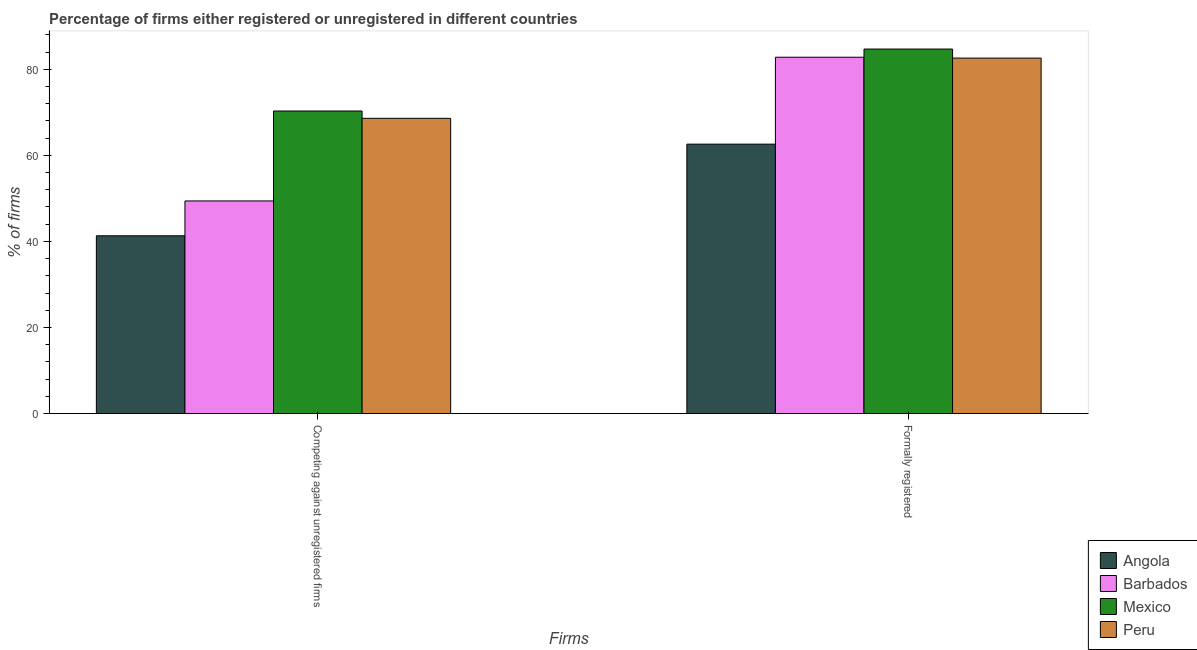How many different coloured bars are there?
Your answer should be compact. 4. What is the label of the 1st group of bars from the left?
Your response must be concise. Competing against unregistered firms. What is the percentage of formally registered firms in Peru?
Your answer should be compact. 82.6. Across all countries, what is the maximum percentage of formally registered firms?
Your answer should be compact. 84.7. Across all countries, what is the minimum percentage of formally registered firms?
Give a very brief answer. 62.6. In which country was the percentage of registered firms maximum?
Keep it short and to the point. Mexico. In which country was the percentage of registered firms minimum?
Offer a terse response. Angola. What is the total percentage of formally registered firms in the graph?
Offer a terse response. 312.7. What is the difference between the percentage of formally registered firms in Angola and that in Peru?
Provide a short and direct response. -20. What is the difference between the percentage of registered firms in Peru and the percentage of formally registered firms in Mexico?
Keep it short and to the point. -16.1. What is the average percentage of registered firms per country?
Provide a succinct answer. 57.4. What is the difference between the percentage of formally registered firms and percentage of registered firms in Mexico?
Provide a succinct answer. 14.4. What is the ratio of the percentage of formally registered firms in Barbados to that in Mexico?
Offer a very short reply. 0.98. Is the percentage of registered firms in Peru less than that in Mexico?
Your answer should be very brief. Yes. In how many countries, is the percentage of formally registered firms greater than the average percentage of formally registered firms taken over all countries?
Make the answer very short. 3. What does the 1st bar from the left in Competing against unregistered firms represents?
Your answer should be very brief. Angola. What does the 2nd bar from the right in Formally registered represents?
Your answer should be compact. Mexico. How many bars are there?
Provide a short and direct response. 8. Are all the bars in the graph horizontal?
Offer a terse response. No. How many countries are there in the graph?
Your answer should be compact. 4. What is the difference between two consecutive major ticks on the Y-axis?
Your answer should be compact. 20. Does the graph contain grids?
Offer a terse response. No. Where does the legend appear in the graph?
Give a very brief answer. Bottom right. How many legend labels are there?
Give a very brief answer. 4. How are the legend labels stacked?
Make the answer very short. Vertical. What is the title of the graph?
Your answer should be very brief. Percentage of firms either registered or unregistered in different countries. What is the label or title of the X-axis?
Ensure brevity in your answer.  Firms. What is the label or title of the Y-axis?
Give a very brief answer. % of firms. What is the % of firms of Angola in Competing against unregistered firms?
Give a very brief answer. 41.3. What is the % of firms in Barbados in Competing against unregistered firms?
Your answer should be very brief. 49.4. What is the % of firms in Mexico in Competing against unregistered firms?
Keep it short and to the point. 70.3. What is the % of firms in Peru in Competing against unregistered firms?
Make the answer very short. 68.6. What is the % of firms in Angola in Formally registered?
Offer a very short reply. 62.6. What is the % of firms in Barbados in Formally registered?
Provide a succinct answer. 82.8. What is the % of firms of Mexico in Formally registered?
Offer a terse response. 84.7. What is the % of firms in Peru in Formally registered?
Your answer should be compact. 82.6. Across all Firms, what is the maximum % of firms in Angola?
Provide a short and direct response. 62.6. Across all Firms, what is the maximum % of firms in Barbados?
Your answer should be compact. 82.8. Across all Firms, what is the maximum % of firms of Mexico?
Make the answer very short. 84.7. Across all Firms, what is the maximum % of firms in Peru?
Keep it short and to the point. 82.6. Across all Firms, what is the minimum % of firms in Angola?
Your answer should be very brief. 41.3. Across all Firms, what is the minimum % of firms of Barbados?
Give a very brief answer. 49.4. Across all Firms, what is the minimum % of firms of Mexico?
Keep it short and to the point. 70.3. Across all Firms, what is the minimum % of firms of Peru?
Offer a very short reply. 68.6. What is the total % of firms in Angola in the graph?
Your answer should be compact. 103.9. What is the total % of firms in Barbados in the graph?
Your answer should be compact. 132.2. What is the total % of firms of Mexico in the graph?
Your response must be concise. 155. What is the total % of firms in Peru in the graph?
Provide a succinct answer. 151.2. What is the difference between the % of firms in Angola in Competing against unregistered firms and that in Formally registered?
Keep it short and to the point. -21.3. What is the difference between the % of firms in Barbados in Competing against unregistered firms and that in Formally registered?
Your response must be concise. -33.4. What is the difference between the % of firms in Mexico in Competing against unregistered firms and that in Formally registered?
Ensure brevity in your answer.  -14.4. What is the difference between the % of firms in Peru in Competing against unregistered firms and that in Formally registered?
Make the answer very short. -14. What is the difference between the % of firms in Angola in Competing against unregistered firms and the % of firms in Barbados in Formally registered?
Provide a succinct answer. -41.5. What is the difference between the % of firms in Angola in Competing against unregistered firms and the % of firms in Mexico in Formally registered?
Provide a short and direct response. -43.4. What is the difference between the % of firms in Angola in Competing against unregistered firms and the % of firms in Peru in Formally registered?
Your answer should be very brief. -41.3. What is the difference between the % of firms in Barbados in Competing against unregistered firms and the % of firms in Mexico in Formally registered?
Offer a terse response. -35.3. What is the difference between the % of firms in Barbados in Competing against unregistered firms and the % of firms in Peru in Formally registered?
Provide a succinct answer. -33.2. What is the average % of firms of Angola per Firms?
Offer a terse response. 51.95. What is the average % of firms of Barbados per Firms?
Your response must be concise. 66.1. What is the average % of firms in Mexico per Firms?
Ensure brevity in your answer.  77.5. What is the average % of firms in Peru per Firms?
Provide a succinct answer. 75.6. What is the difference between the % of firms in Angola and % of firms in Mexico in Competing against unregistered firms?
Your response must be concise. -29. What is the difference between the % of firms in Angola and % of firms in Peru in Competing against unregistered firms?
Your answer should be compact. -27.3. What is the difference between the % of firms of Barbados and % of firms of Mexico in Competing against unregistered firms?
Offer a very short reply. -20.9. What is the difference between the % of firms in Barbados and % of firms in Peru in Competing against unregistered firms?
Offer a very short reply. -19.2. What is the difference between the % of firms of Angola and % of firms of Barbados in Formally registered?
Make the answer very short. -20.2. What is the difference between the % of firms in Angola and % of firms in Mexico in Formally registered?
Your answer should be compact. -22.1. What is the difference between the % of firms in Barbados and % of firms in Peru in Formally registered?
Your answer should be compact. 0.2. What is the ratio of the % of firms in Angola in Competing against unregistered firms to that in Formally registered?
Offer a terse response. 0.66. What is the ratio of the % of firms in Barbados in Competing against unregistered firms to that in Formally registered?
Keep it short and to the point. 0.6. What is the ratio of the % of firms in Mexico in Competing against unregistered firms to that in Formally registered?
Provide a short and direct response. 0.83. What is the ratio of the % of firms of Peru in Competing against unregistered firms to that in Formally registered?
Your answer should be compact. 0.83. What is the difference between the highest and the second highest % of firms of Angola?
Offer a terse response. 21.3. What is the difference between the highest and the second highest % of firms in Barbados?
Give a very brief answer. 33.4. What is the difference between the highest and the lowest % of firms of Angola?
Your answer should be very brief. 21.3. What is the difference between the highest and the lowest % of firms of Barbados?
Provide a succinct answer. 33.4. 